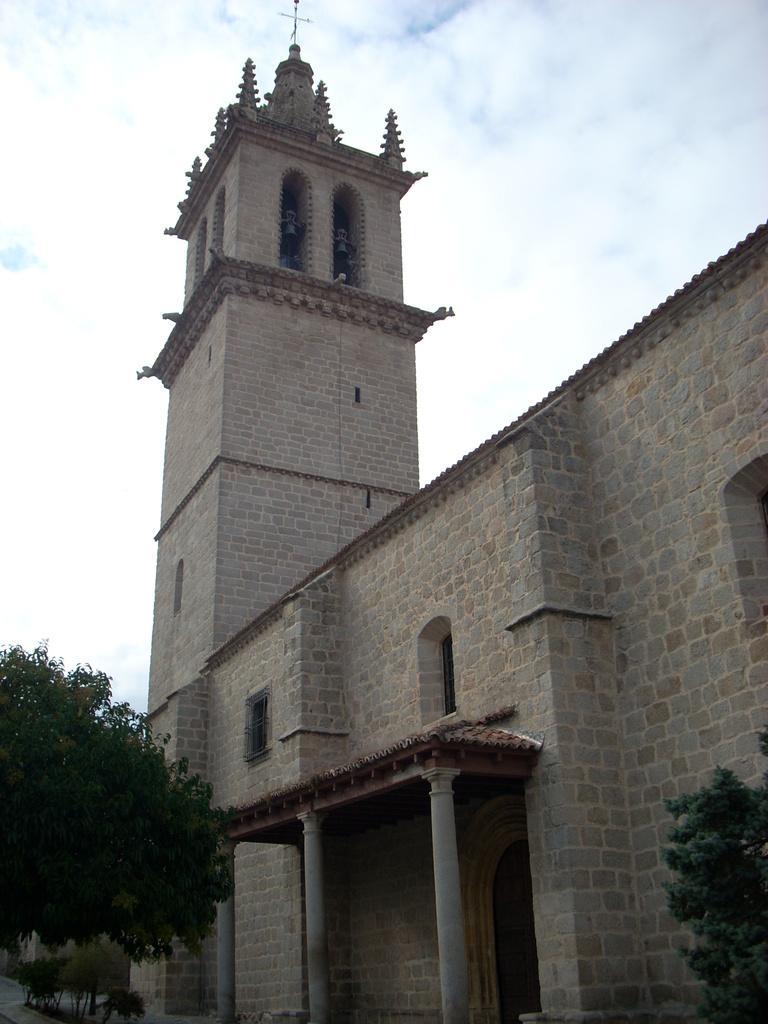How would you summarize this image in a sentence or two? At the bottom we can see trees and plants. In the background there is a building, windows, cross symbol on the building, windows and clouds in the sky. 